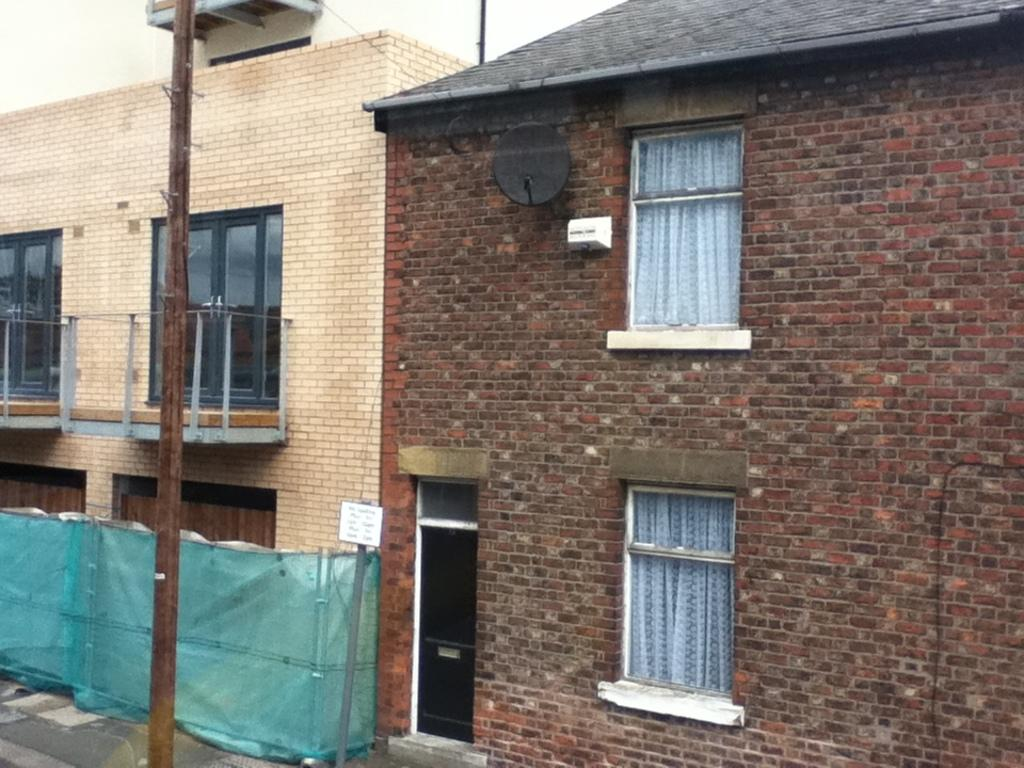What is the main subject in the center of the image? There are buildings in the center of the image. What can be seen on the left side of the image? There is a pole on the left side of the image. What is visible in the background of the image? The sky is visible in the background of the image. What is located at the bottom of the image? There is a fence at the bottom of the image. How many rabbits are hopping around the buildings in the image? There are no rabbits present in the image; it only features buildings, a pole, the sky, and a fence. 